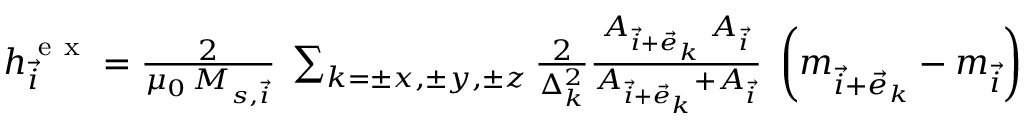<formula> <loc_0><loc_0><loc_500><loc_500>\begin{array} { r } { h _ { \vec { i } } ^ { e x } = \frac { 2 } { \mu _ { 0 } \, M _ { s , \vec { i } } } \, \sum _ { k = \pm x , \pm y , \pm z } \frac { 2 } { \Delta _ { k } ^ { 2 } } \frac { A _ { \vec { i } + \vec { e } _ { k } } \, A _ { \vec { i } } } { A _ { \vec { i } + \vec { e } _ { k } } + A _ { \vec { i } } } \, \left ( m _ { \vec { i } + \vec { e } _ { k } } - m _ { \vec { i } } \right ) } \end{array}</formula> 